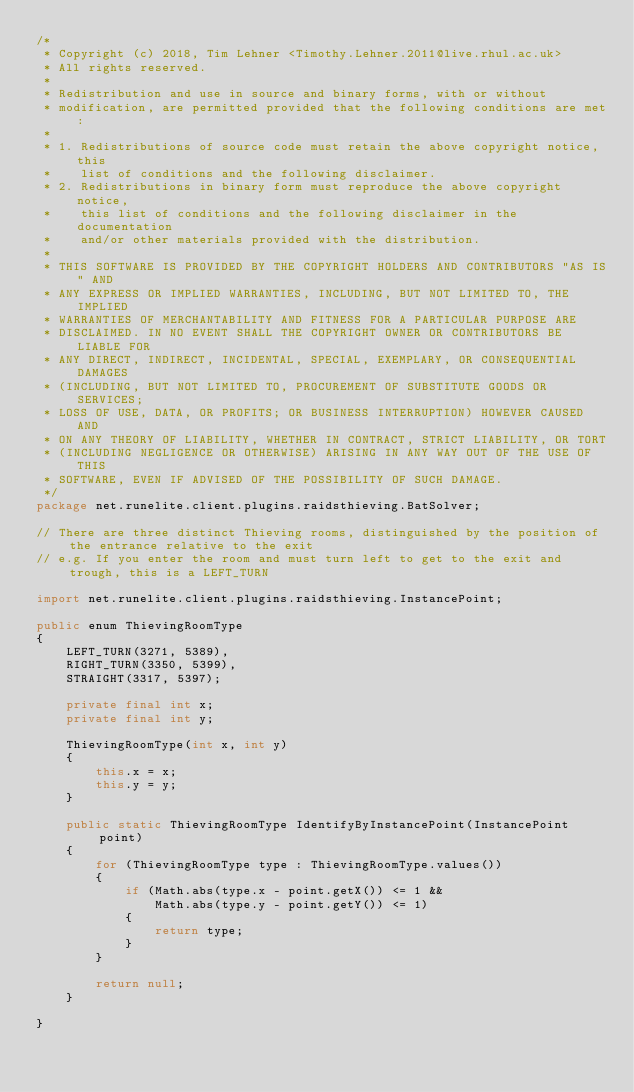<code> <loc_0><loc_0><loc_500><loc_500><_Java_>/*
 * Copyright (c) 2018, Tim Lehner <Timothy.Lehner.2011@live.rhul.ac.uk>
 * All rights reserved.
 *
 * Redistribution and use in source and binary forms, with or without
 * modification, are permitted provided that the following conditions are met:
 *
 * 1. Redistributions of source code must retain the above copyright notice, this
 *    list of conditions and the following disclaimer.
 * 2. Redistributions in binary form must reproduce the above copyright notice,
 *    this list of conditions and the following disclaimer in the documentation
 *    and/or other materials provided with the distribution.
 *
 * THIS SOFTWARE IS PROVIDED BY THE COPYRIGHT HOLDERS AND CONTRIBUTORS "AS IS" AND
 * ANY EXPRESS OR IMPLIED WARRANTIES, INCLUDING, BUT NOT LIMITED TO, THE IMPLIED
 * WARRANTIES OF MERCHANTABILITY AND FITNESS FOR A PARTICULAR PURPOSE ARE
 * DISCLAIMED. IN NO EVENT SHALL THE COPYRIGHT OWNER OR CONTRIBUTORS BE LIABLE FOR
 * ANY DIRECT, INDIRECT, INCIDENTAL, SPECIAL, EXEMPLARY, OR CONSEQUENTIAL DAMAGES
 * (INCLUDING, BUT NOT LIMITED TO, PROCUREMENT OF SUBSTITUTE GOODS OR SERVICES;
 * LOSS OF USE, DATA, OR PROFITS; OR BUSINESS INTERRUPTION) HOWEVER CAUSED AND
 * ON ANY THEORY OF LIABILITY, WHETHER IN CONTRACT, STRICT LIABILITY, OR TORT
 * (INCLUDING NEGLIGENCE OR OTHERWISE) ARISING IN ANY WAY OUT OF THE USE OF THIS
 * SOFTWARE, EVEN IF ADVISED OF THE POSSIBILITY OF SUCH DAMAGE.
 */
package net.runelite.client.plugins.raidsthieving.BatSolver;

// There are three distinct Thieving rooms, distinguished by the position of the entrance relative to the exit
// e.g. If you enter the room and must turn left to get to the exit and trough, this is a LEFT_TURN

import net.runelite.client.plugins.raidsthieving.InstancePoint;

public enum ThievingRoomType
{
	LEFT_TURN(3271, 5389),
	RIGHT_TURN(3350, 5399),
	STRAIGHT(3317, 5397);

	private final int x;
	private final int y;

	ThievingRoomType(int x, int y)
	{
		this.x = x;
		this.y = y;
	}

	public static ThievingRoomType IdentifyByInstancePoint(InstancePoint point)
	{
		for (ThievingRoomType type : ThievingRoomType.values())
		{
			if (Math.abs(type.x - point.getX()) <= 1 &&
				Math.abs(type.y - point.getY()) <= 1)
			{
				return type;
			}
		}

		return null;
	}

}
</code> 